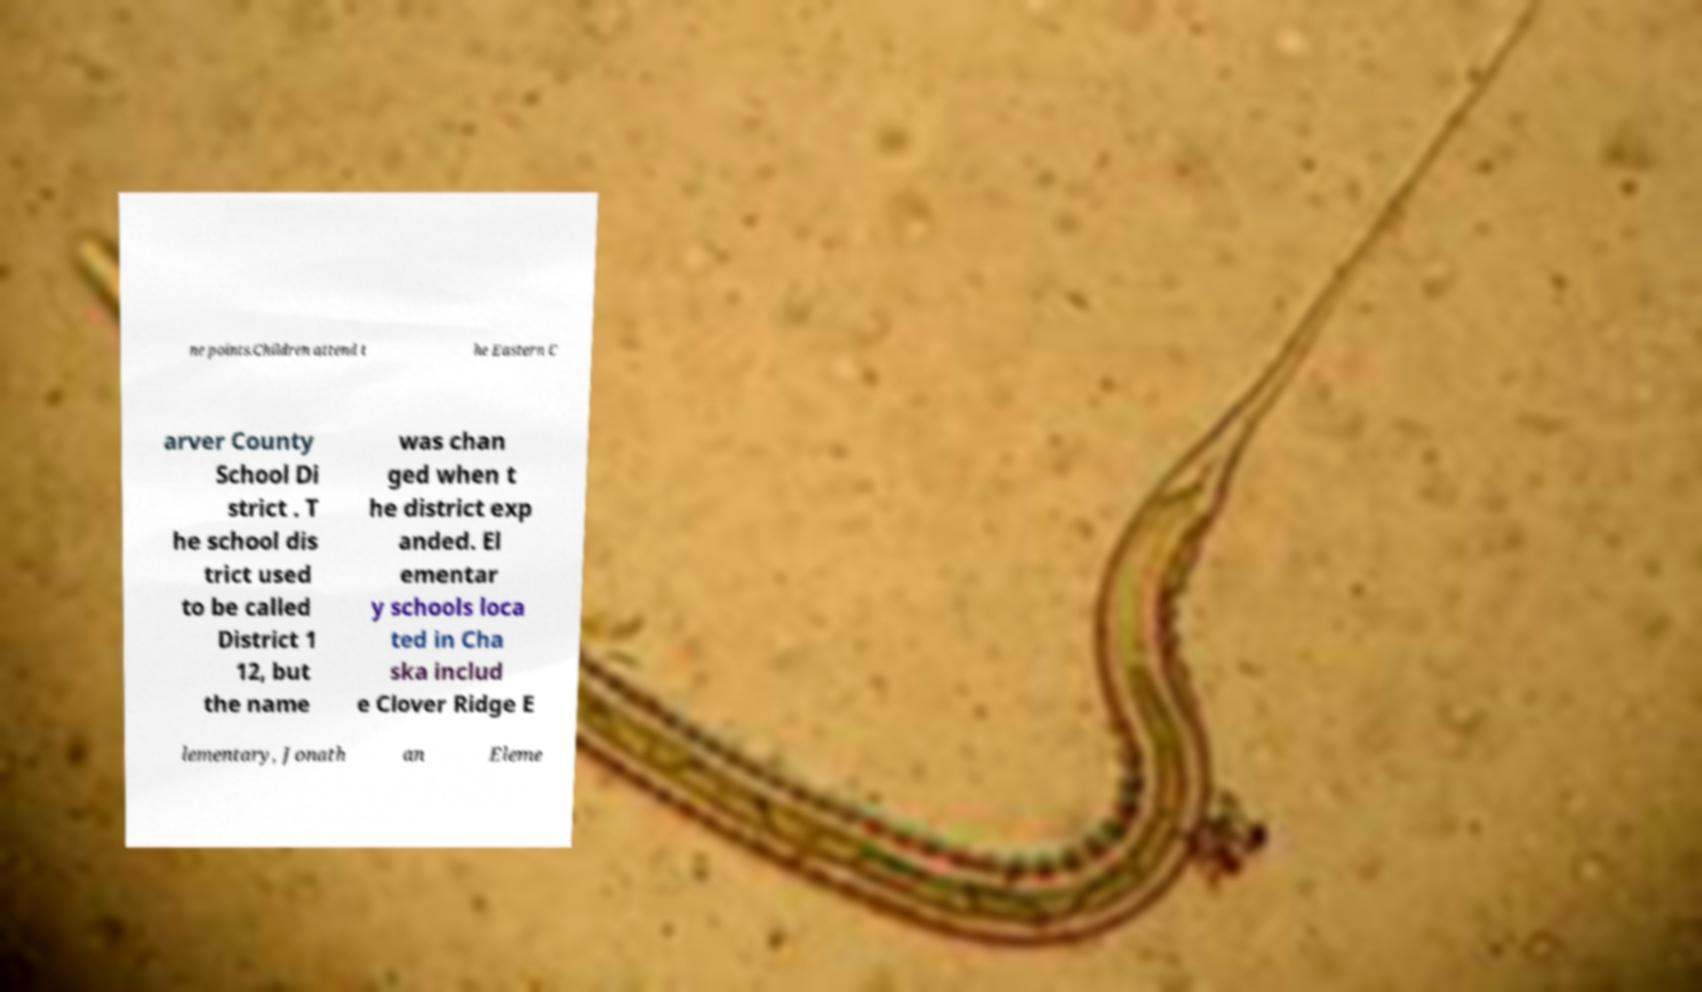Please read and relay the text visible in this image. What does it say? ne points.Children attend t he Eastern C arver County School Di strict . T he school dis trict used to be called District 1 12, but the name was chan ged when t he district exp anded. El ementar y schools loca ted in Cha ska includ e Clover Ridge E lementary, Jonath an Eleme 